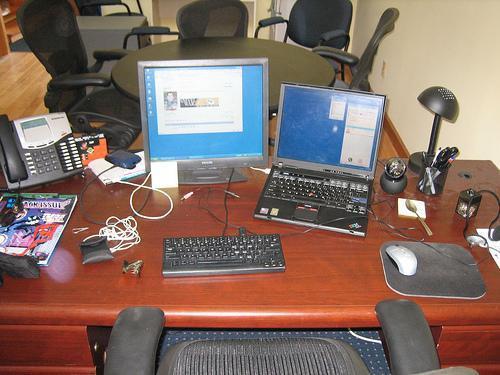How many computer screens are there?
Give a very brief answer. 2. How many dining tables are there?
Give a very brief answer. 1. How many chairs are visible?
Give a very brief answer. 4. How many keyboards are in the picture?
Give a very brief answer. 2. 